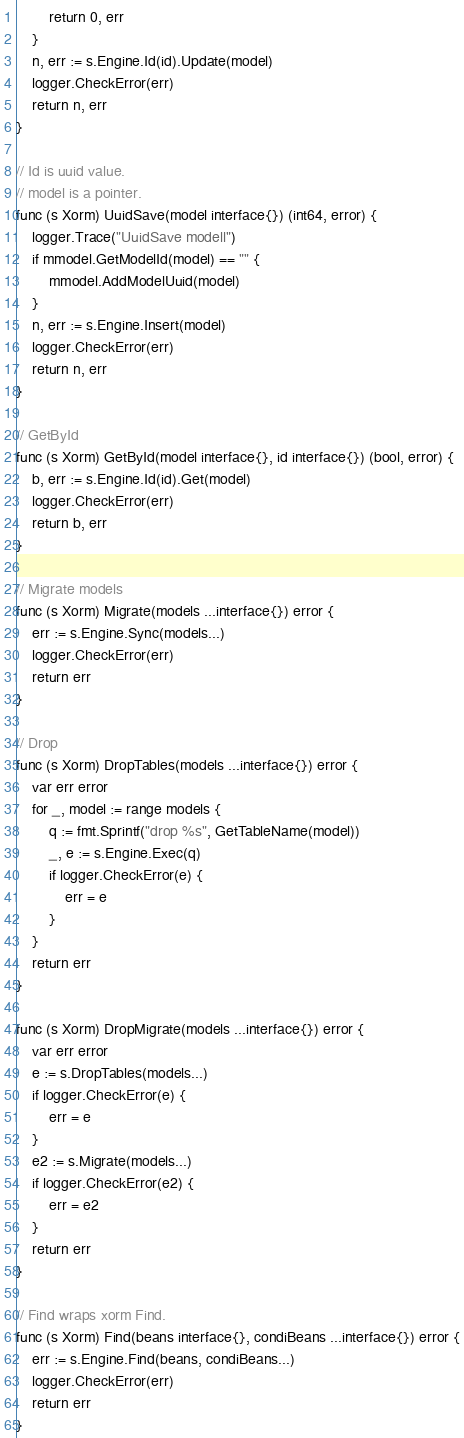<code> <loc_0><loc_0><loc_500><loc_500><_Go_>		return 0, err
	}
	n, err := s.Engine.Id(id).Update(model)
	logger.CheckError(err)
	return n, err
}

// Id is uuid value.
// model is a pointer.
func (s Xorm) UuidSave(model interface{}) (int64, error) {
	logger.Trace("UuidSave modell")
	if mmodel.GetModelId(model) == "" {
		mmodel.AddModelUuid(model)
	}
	n, err := s.Engine.Insert(model)
	logger.CheckError(err)
	return n, err
}

// GetById
func (s Xorm) GetById(model interface{}, id interface{}) (bool, error) {
	b, err := s.Engine.Id(id).Get(model)
	logger.CheckError(err)
	return b, err
}

// Migrate models
func (s Xorm) Migrate(models ...interface{}) error {
	err := s.Engine.Sync(models...)
	logger.CheckError(err)
	return err
}

// Drop
func (s Xorm) DropTables(models ...interface{}) error {
	var err error
	for _, model := range models {
		q := fmt.Sprintf("drop %s", GetTableName(model))
		_, e := s.Engine.Exec(q)
		if logger.CheckError(e) {
			err = e
		}
	}
	return err
}

func (s Xorm) DropMigrate(models ...interface{}) error {
	var err error
	e := s.DropTables(models...)
	if logger.CheckError(e) {
		err = e
	}
	e2 := s.Migrate(models...)
	if logger.CheckError(e2) {
		err = e2
	}
	return err
}

// Find wraps xorm Find.
func (s Xorm) Find(beans interface{}, condiBeans ...interface{}) error {
	err := s.Engine.Find(beans, condiBeans...)
	logger.CheckError(err)
	return err
}
</code> 